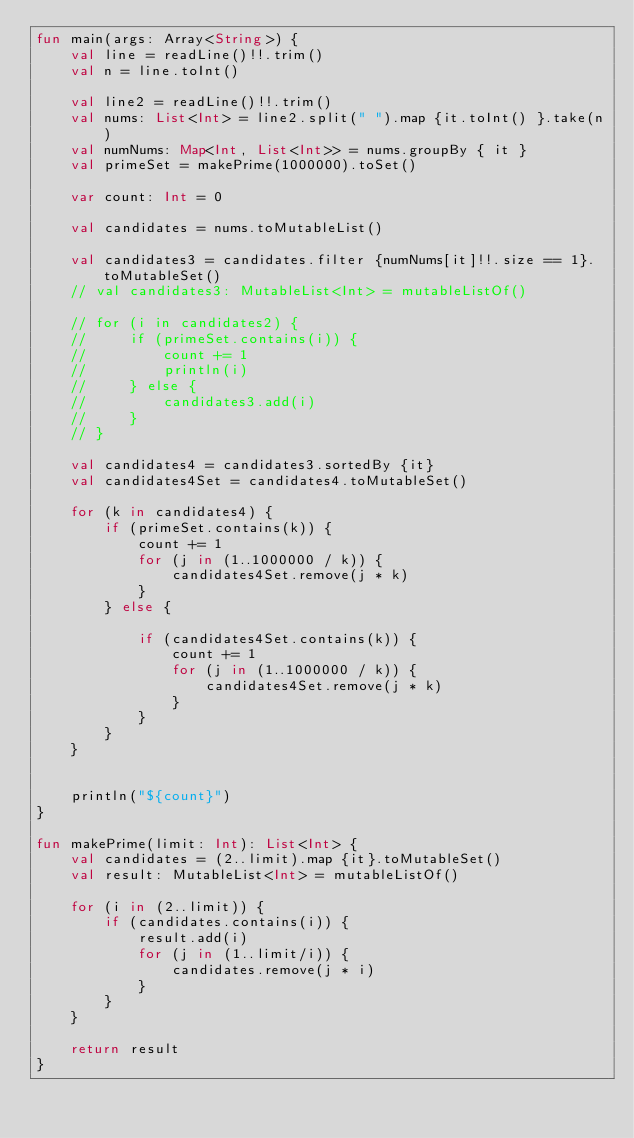Convert code to text. <code><loc_0><loc_0><loc_500><loc_500><_Kotlin_>fun main(args: Array<String>) {
    val line = readLine()!!.trim()
    val n = line.toInt()

    val line2 = readLine()!!.trim()
    val nums: List<Int> = line2.split(" ").map {it.toInt() }.take(n)
    val numNums: Map<Int, List<Int>> = nums.groupBy { it }
    val primeSet = makePrime(1000000).toSet()

    var count: Int = 0

    val candidates = nums.toMutableList()

    val candidates3 = candidates.filter {numNums[it]!!.size == 1}.toMutableSet()
    // val candidates3: MutableList<Int> = mutableListOf()

    // for (i in candidates2) {
    //     if (primeSet.contains(i)) {
    //         count += 1
    //         println(i)
    //     } else {
    //         candidates3.add(i)
    //     }
    // }

    val candidates4 = candidates3.sortedBy {it}
    val candidates4Set = candidates4.toMutableSet()

    for (k in candidates4) {
        if (primeSet.contains(k)) {
            count += 1
            for (j in (1..1000000 / k)) {
                candidates4Set.remove(j * k)
            }
        } else {

            if (candidates4Set.contains(k)) {
                count += 1
                for (j in (1..1000000 / k)) {
                    candidates4Set.remove(j * k)
                }
            }
        }
    }


    println("${count}")
}

fun makePrime(limit: Int): List<Int> {
    val candidates = (2..limit).map {it}.toMutableSet()
    val result: MutableList<Int> = mutableListOf()

    for (i in (2..limit)) {
        if (candidates.contains(i)) {
            result.add(i)
            for (j in (1..limit/i)) {
                candidates.remove(j * i)
            }
        }
    }

    return result
}
</code> 